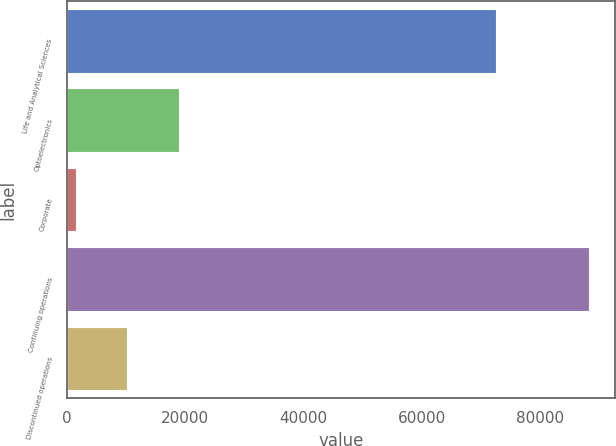<chart> <loc_0><loc_0><loc_500><loc_500><bar_chart><fcel>Life and Analytical Sciences<fcel>Optoelectronics<fcel>Corporate<fcel>Continuing operations<fcel>Discontinued operations<nl><fcel>72534<fcel>18901.4<fcel>1550<fcel>88307<fcel>10225.7<nl></chart> 